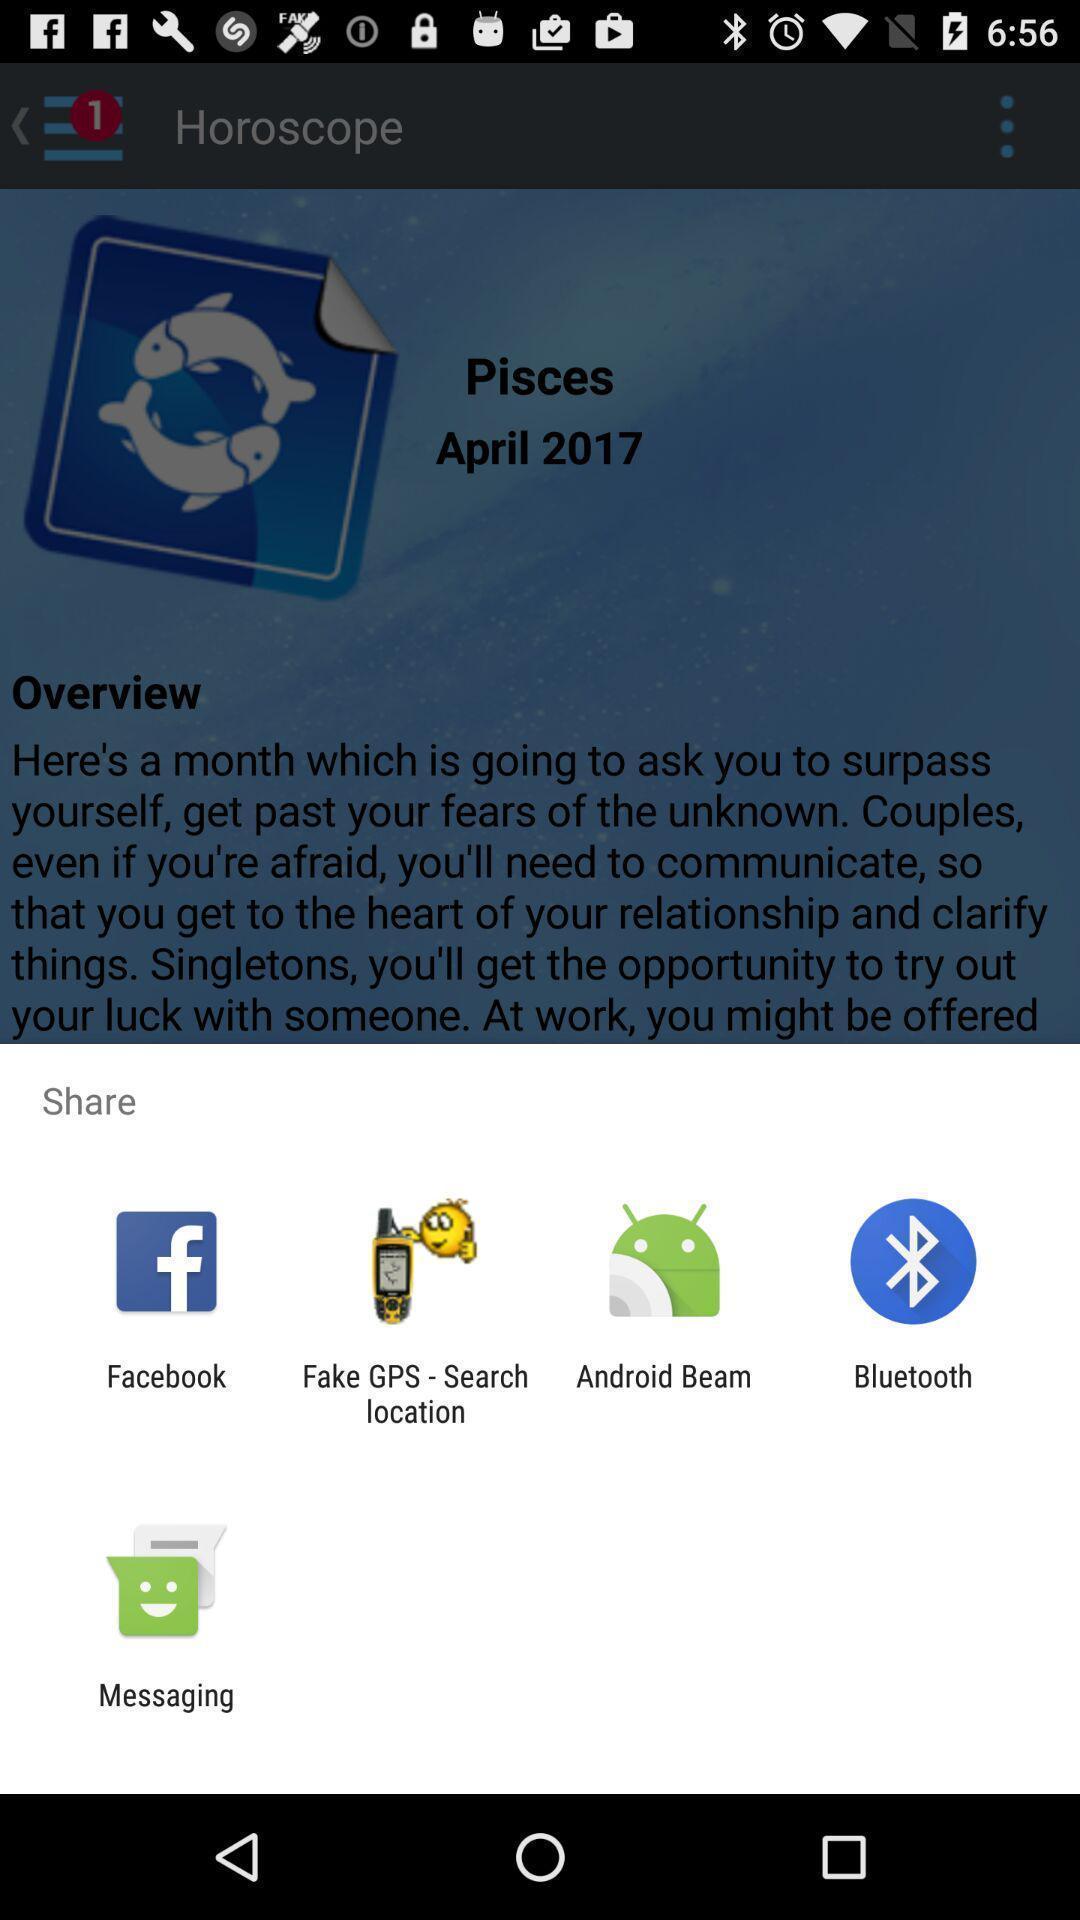Summarize the main components in this picture. Share page to select through which app to complete action. 